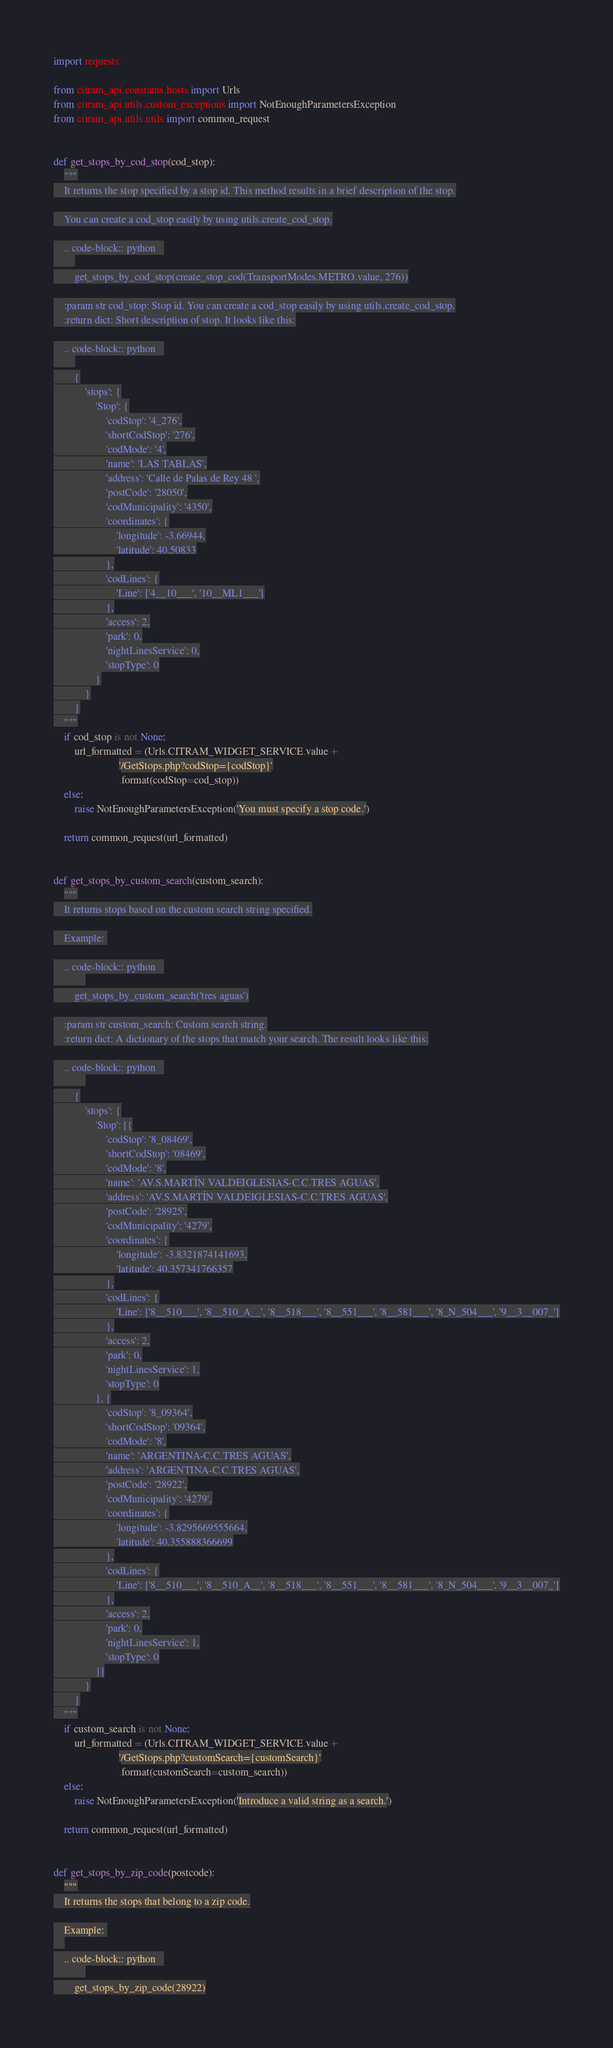<code> <loc_0><loc_0><loc_500><loc_500><_Python_>import requests

from citram_api.constants.hosts import Urls
from citram_api.utils.custom_exceptions import NotEnoughParametersException
from citram_api.utils.utils import common_request


def get_stops_by_cod_stop(cod_stop):
    """
    It returns the stop specified by a stop id. This method results in a brief description of the stop.

    You can create a cod_stop easily by using utils.create_cod_stop.

    .. code-block:: python   
        
        get_stops_by_cod_stop(create_stop_cod(TransportModes.METRO.value, 276))

    :param str cod_stop: Stop id. You can create a cod_stop easily by using utils.create_cod_stop.
    :return dict: Short description of stop. It looks like this:

    .. code-block:: python   
        
        {
            'stops': {
                'Stop': {
                    'codStop': '4_276',
                    'shortCodStop': '276',
                    'codMode': '4',
                    'name': 'LAS TABLAS',
                    'address': 'Calle de Palas de Rey 48 ',
                    'postCode': '28050',
                    'codMunicipality': '4350',
                    'coordinates': {
                        'longitude': -3.66944,
                        'latitude': 40.50833
                    },
                    'codLines': {
                        'Line': ['4__10___', '10__ML1___']
                    },
                    'access': 2,
                    'park': 0,
                    'nightLinesService': 0,
                    'stopType': 0
                }
            }
        }
    """
    if cod_stop is not None:
        url_formatted = (Urls.CITRAM_WIDGET_SERVICE.value +
                         '/GetStops.php?codStop={codStop}'
                         .format(codStop=cod_stop))
    else:
        raise NotEnoughParametersException('You must specify a stop code.')

    return common_request(url_formatted)


def get_stops_by_custom_search(custom_search):
    """
    It returns stops based on the custom search string specified.

    Example: 

    .. code-block:: python   
            
        get_stops_by_custom_search('tres aguas')

    :param str custom_search: Custom search string.
    :return dict: A dictionary of the stops that match your search. The result looks like this:

    .. code-block:: python   
            
        {
            'stops': {
                'Stop': [{
                    'codStop': '8_08469',
                    'shortCodStop': '08469',
                    'codMode': '8',
                    'name': 'AV.S.MARTÍN VALDEIGLESIAS-C.C.TRES AGUAS',
                    'address': 'AV.S.MARTÍN VALDEIGLESIAS-C.C.TRES AGUAS',
                    'postCode': '28925',
                    'codMunicipality': '4279',
                    'coordinates': {
                        'longitude': -3.8321874141693,
                        'latitude': 40.357341766357
                    },
                    'codLines': {
                        'Line': ['8__510___', '8__510_A__', '8__518___', '8__551___', '8__581___', '8_N_504___', '9__3__007_']
                    },
                    'access': 2,
                    'park': 0,
                    'nightLinesService': 1,
                    'stopType': 0
                }, {
                    'codStop': '8_09364',
                    'shortCodStop': '09364',
                    'codMode': '8',
                    'name': 'ARGENTINA-C.C.TRES AGUAS',
                    'address': 'ARGENTINA-C.C.TRES AGUAS',
                    'postCode': '28922',
                    'codMunicipality': '4279',
                    'coordinates': {
                        'longitude': -3.8295669555664,
                        'latitude': 40.355888366699
                    },
                    'codLines': {
                        'Line': ['8__510___', '8__510_A__', '8__518___', '8__551___', '8__581___', '8_N_504___', '9__3__007_']
                    },
                    'access': 2,
                    'park': 0,
                    'nightLinesService': 1,
                    'stopType': 0
                }]
            }
        }
    """
    if custom_search is not None:
        url_formatted = (Urls.CITRAM_WIDGET_SERVICE.value +
                         '/GetStops.php?customSearch={customSearch}'
                         .format(customSearch=custom_search))
    else:
        raise NotEnoughParametersException('Introduce a valid string as a search.')

    return common_request(url_formatted)


def get_stops_by_zip_code(postcode):
    """
    It returns the stops that belong to a zip code.

    Example: 
    
    .. code-block:: python   
            
        get_stops_by_zip_code(28922)
</code> 